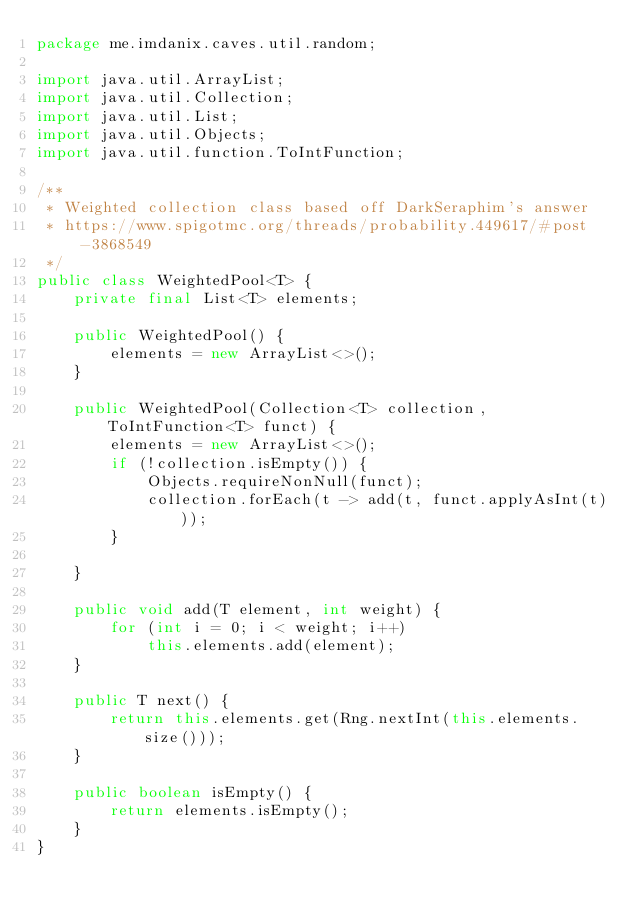<code> <loc_0><loc_0><loc_500><loc_500><_Java_>package me.imdanix.caves.util.random;

import java.util.ArrayList;
import java.util.Collection;
import java.util.List;
import java.util.Objects;
import java.util.function.ToIntFunction;

/**
 * Weighted collection class based off DarkSeraphim's answer
 * https://www.spigotmc.org/threads/probability.449617/#post-3868549
 */
public class WeightedPool<T> {
    private final List<T> elements;

    public WeightedPool() {
        elements = new ArrayList<>();
    }

    public WeightedPool(Collection<T> collection, ToIntFunction<T> funct) {
        elements = new ArrayList<>();
        if (!collection.isEmpty()) {
            Objects.requireNonNull(funct);
            collection.forEach(t -> add(t, funct.applyAsInt(t)));
        }

    }

    public void add(T element, int weight) {
        for (int i = 0; i < weight; i++)
            this.elements.add(element);
    }

    public T next() {
        return this.elements.get(Rng.nextInt(this.elements.size()));
    }

    public boolean isEmpty() {
        return elements.isEmpty();
    }
}
</code> 